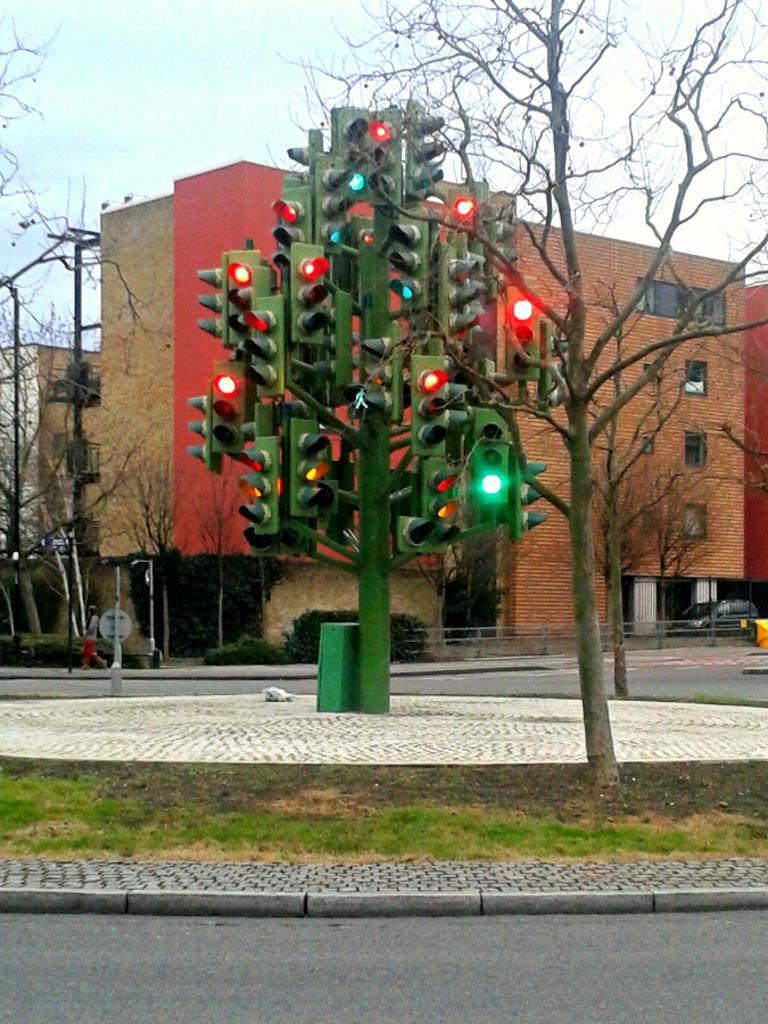In one or two sentences, can you explain what this image depicts? In this image we can see some buildings and in front of it there are traffic lights, trees, railings and a few other objects. 